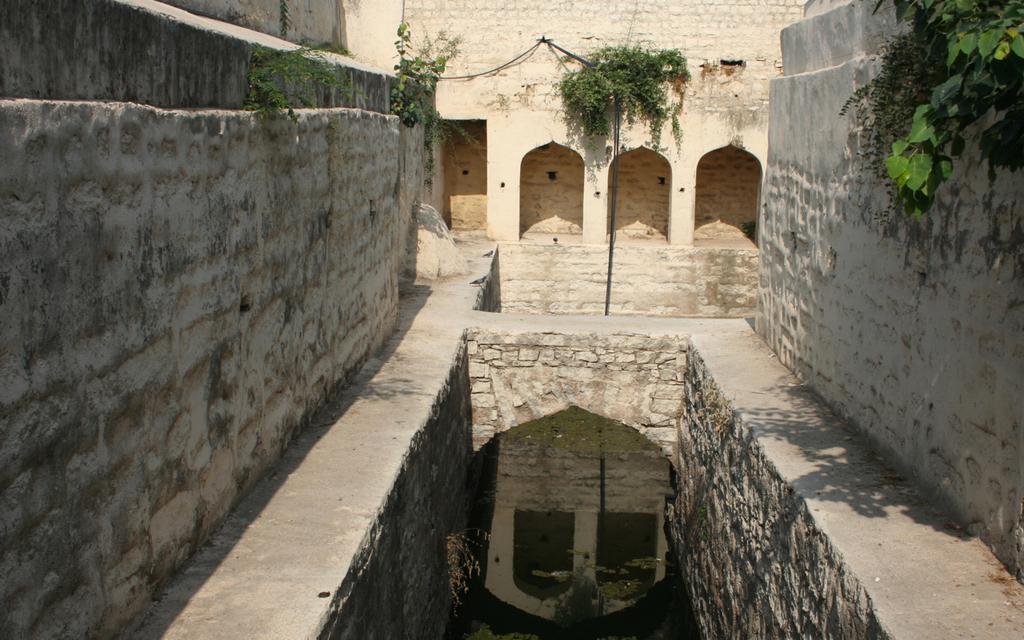Can you describe this image briefly? Here in this picture we can see walls present all over there and we can see plants on the wall here and there and in the middle we can see a pond like structure, in which we can see water present over there. 